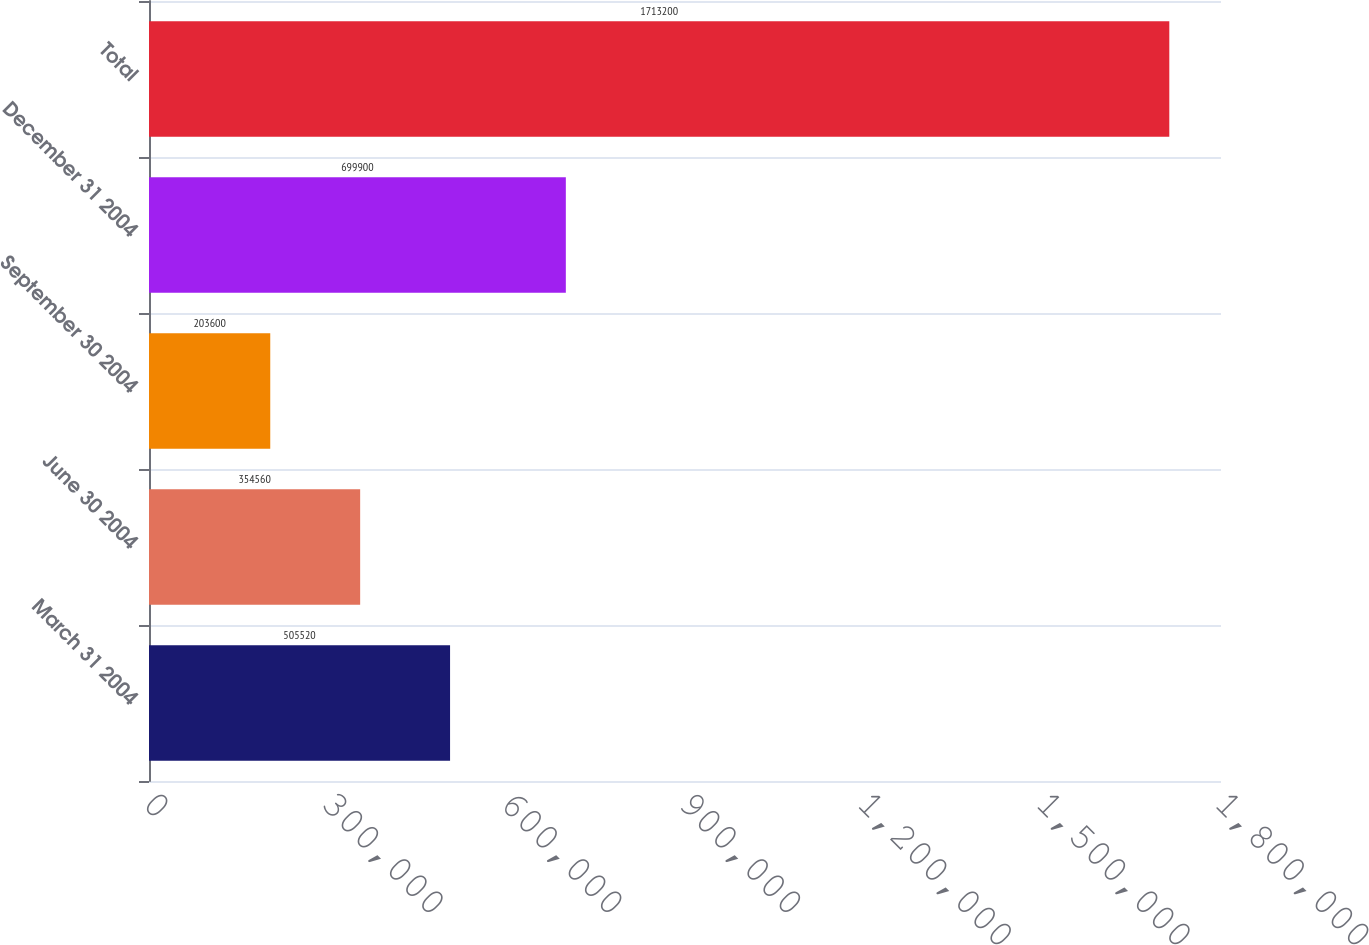Convert chart. <chart><loc_0><loc_0><loc_500><loc_500><bar_chart><fcel>March 31 2004<fcel>June 30 2004<fcel>September 30 2004<fcel>December 31 2004<fcel>Total<nl><fcel>505520<fcel>354560<fcel>203600<fcel>699900<fcel>1.7132e+06<nl></chart> 